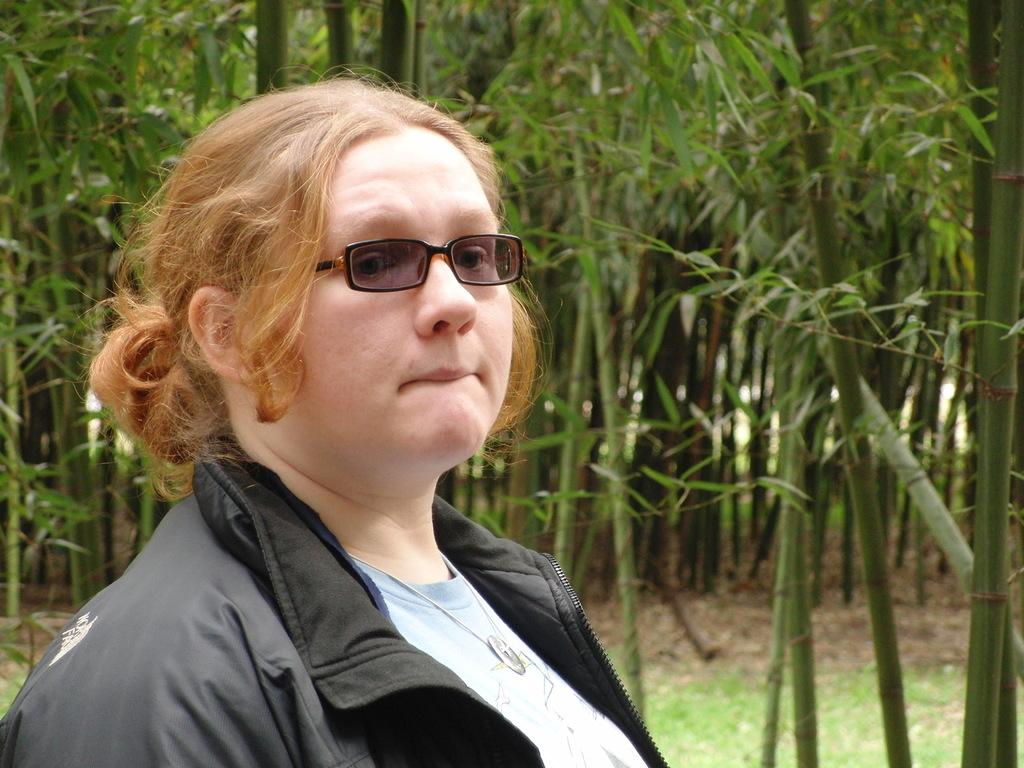Who is the main subject in the foreground of the image? There is a lady in the foreground of the image. What accessory is the lady wearing? The lady is wearing glasses. What type of environment can be seen in the background of the image? There is greenery in the background of the image. What type of winter clothing is the lady wearing in the image? The image does not show any winter clothing, as there is no mention of winter or cold weather in the provided facts. 